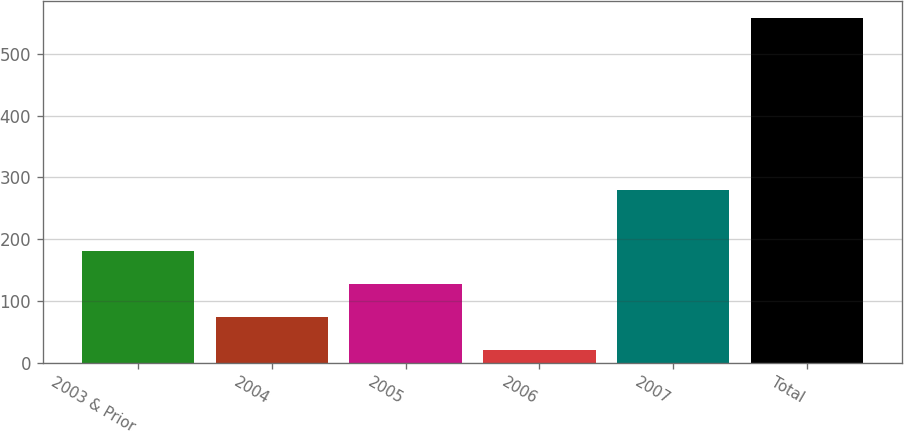Convert chart. <chart><loc_0><loc_0><loc_500><loc_500><bar_chart><fcel>2003 & Prior<fcel>2004<fcel>2005<fcel>2006<fcel>2007<fcel>Total<nl><fcel>180.98<fcel>73.46<fcel>127.22<fcel>19.7<fcel>280.2<fcel>557.3<nl></chart> 